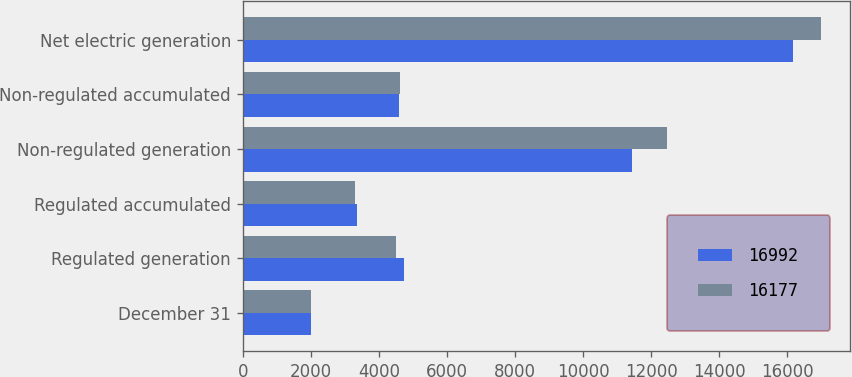Convert chart. <chart><loc_0><loc_0><loc_500><loc_500><stacked_bar_chart><ecel><fcel>December 31<fcel>Regulated generation<fcel>Regulated accumulated<fcel>Non-regulated generation<fcel>Non-regulated accumulated<fcel>Net electric generation<nl><fcel>16992<fcel>2017<fcel>4736<fcel>3357<fcel>11441<fcel>4585<fcel>16177<nl><fcel>16177<fcel>2016<fcel>4516<fcel>3299<fcel>12476<fcel>4620<fcel>16992<nl></chart> 